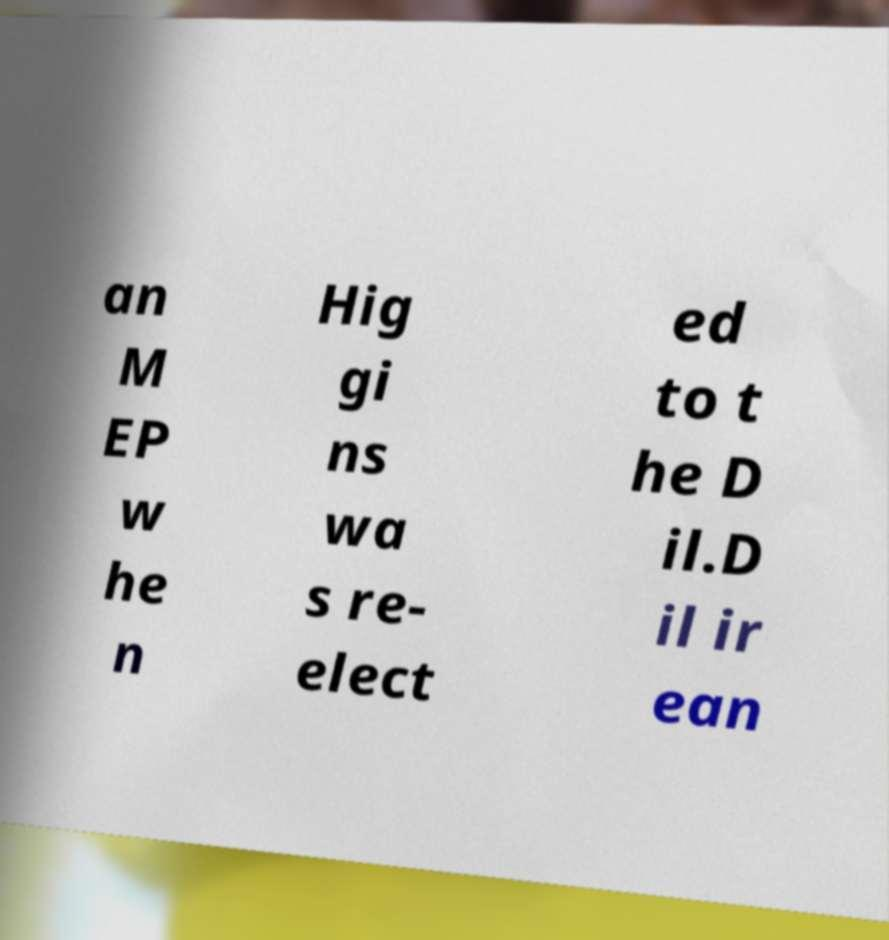For documentation purposes, I need the text within this image transcribed. Could you provide that? an M EP w he n Hig gi ns wa s re- elect ed to t he D il.D il ir ean 